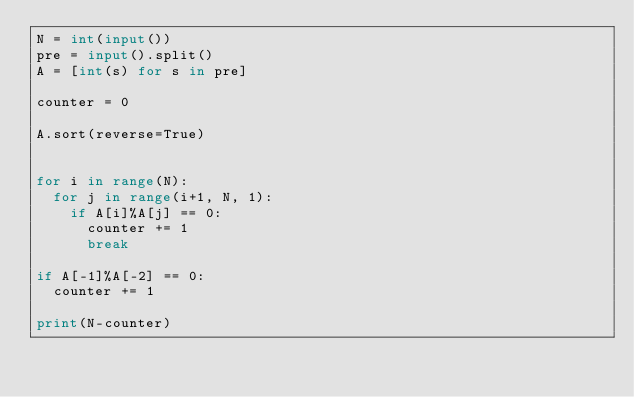<code> <loc_0><loc_0><loc_500><loc_500><_Python_>N = int(input())
pre = input().split()
A = [int(s) for s in pre]

counter = 0

A.sort(reverse=True)


for i in range(N):
  for j in range(i+1, N, 1):
    if A[i]%A[j] == 0:
      counter += 1
      break
      
if A[-1]%A[-2] == 0:
  counter += 1
      
print(N-counter)

</code> 